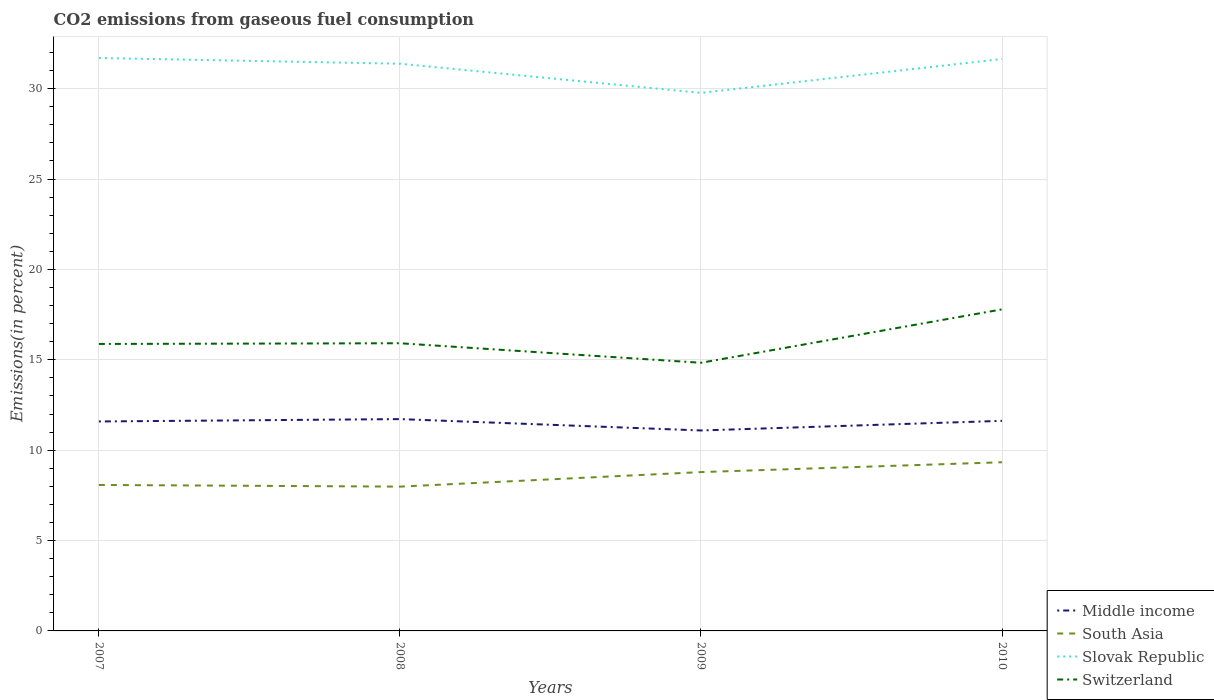How many different coloured lines are there?
Your answer should be compact. 4. Does the line corresponding to Slovak Republic intersect with the line corresponding to Middle income?
Your response must be concise. No. Is the number of lines equal to the number of legend labels?
Your answer should be compact. Yes. Across all years, what is the maximum total CO2 emitted in Middle income?
Ensure brevity in your answer.  11.09. What is the total total CO2 emitted in Switzerland in the graph?
Ensure brevity in your answer.  -1.87. What is the difference between the highest and the second highest total CO2 emitted in Slovak Republic?
Offer a terse response. 1.93. What is the difference between the highest and the lowest total CO2 emitted in Middle income?
Ensure brevity in your answer.  3. Is the total CO2 emitted in South Asia strictly greater than the total CO2 emitted in Switzerland over the years?
Your response must be concise. Yes. How many years are there in the graph?
Provide a short and direct response. 4. What is the difference between two consecutive major ticks on the Y-axis?
Provide a short and direct response. 5. Are the values on the major ticks of Y-axis written in scientific E-notation?
Ensure brevity in your answer.  No. Does the graph contain any zero values?
Your answer should be very brief. No. Where does the legend appear in the graph?
Provide a short and direct response. Bottom right. How are the legend labels stacked?
Your response must be concise. Vertical. What is the title of the graph?
Offer a very short reply. CO2 emissions from gaseous fuel consumption. Does "Uganda" appear as one of the legend labels in the graph?
Your answer should be compact. No. What is the label or title of the X-axis?
Your answer should be compact. Years. What is the label or title of the Y-axis?
Offer a terse response. Emissions(in percent). What is the Emissions(in percent) of Middle income in 2007?
Offer a very short reply. 11.59. What is the Emissions(in percent) in South Asia in 2007?
Make the answer very short. 8.08. What is the Emissions(in percent) in Slovak Republic in 2007?
Make the answer very short. 31.69. What is the Emissions(in percent) of Switzerland in 2007?
Ensure brevity in your answer.  15.88. What is the Emissions(in percent) in Middle income in 2008?
Your answer should be compact. 11.72. What is the Emissions(in percent) in South Asia in 2008?
Provide a succinct answer. 7.98. What is the Emissions(in percent) of Slovak Republic in 2008?
Your response must be concise. 31.38. What is the Emissions(in percent) in Switzerland in 2008?
Provide a succinct answer. 15.91. What is the Emissions(in percent) in Middle income in 2009?
Offer a terse response. 11.09. What is the Emissions(in percent) in South Asia in 2009?
Keep it short and to the point. 8.79. What is the Emissions(in percent) of Slovak Republic in 2009?
Ensure brevity in your answer.  29.77. What is the Emissions(in percent) in Switzerland in 2009?
Your answer should be compact. 14.83. What is the Emissions(in percent) of Middle income in 2010?
Make the answer very short. 11.62. What is the Emissions(in percent) in South Asia in 2010?
Offer a terse response. 9.33. What is the Emissions(in percent) in Slovak Republic in 2010?
Offer a very short reply. 31.64. What is the Emissions(in percent) in Switzerland in 2010?
Make the answer very short. 17.79. Across all years, what is the maximum Emissions(in percent) of Middle income?
Your answer should be compact. 11.72. Across all years, what is the maximum Emissions(in percent) in South Asia?
Give a very brief answer. 9.33. Across all years, what is the maximum Emissions(in percent) of Slovak Republic?
Offer a very short reply. 31.69. Across all years, what is the maximum Emissions(in percent) of Switzerland?
Your answer should be compact. 17.79. Across all years, what is the minimum Emissions(in percent) of Middle income?
Make the answer very short. 11.09. Across all years, what is the minimum Emissions(in percent) of South Asia?
Make the answer very short. 7.98. Across all years, what is the minimum Emissions(in percent) in Slovak Republic?
Keep it short and to the point. 29.77. Across all years, what is the minimum Emissions(in percent) in Switzerland?
Keep it short and to the point. 14.83. What is the total Emissions(in percent) of Middle income in the graph?
Your answer should be compact. 46.02. What is the total Emissions(in percent) of South Asia in the graph?
Offer a very short reply. 34.18. What is the total Emissions(in percent) of Slovak Republic in the graph?
Your response must be concise. 124.48. What is the total Emissions(in percent) of Switzerland in the graph?
Provide a short and direct response. 64.41. What is the difference between the Emissions(in percent) of Middle income in 2007 and that in 2008?
Provide a short and direct response. -0.13. What is the difference between the Emissions(in percent) of South Asia in 2007 and that in 2008?
Your answer should be compact. 0.09. What is the difference between the Emissions(in percent) of Slovak Republic in 2007 and that in 2008?
Offer a terse response. 0.32. What is the difference between the Emissions(in percent) of Switzerland in 2007 and that in 2008?
Ensure brevity in your answer.  -0.04. What is the difference between the Emissions(in percent) in Middle income in 2007 and that in 2009?
Provide a short and direct response. 0.5. What is the difference between the Emissions(in percent) of South Asia in 2007 and that in 2009?
Give a very brief answer. -0.71. What is the difference between the Emissions(in percent) in Slovak Republic in 2007 and that in 2009?
Provide a short and direct response. 1.93. What is the difference between the Emissions(in percent) in Switzerland in 2007 and that in 2009?
Make the answer very short. 1.04. What is the difference between the Emissions(in percent) of Middle income in 2007 and that in 2010?
Provide a succinct answer. -0.03. What is the difference between the Emissions(in percent) in South Asia in 2007 and that in 2010?
Provide a short and direct response. -1.26. What is the difference between the Emissions(in percent) in Slovak Republic in 2007 and that in 2010?
Give a very brief answer. 0.05. What is the difference between the Emissions(in percent) in Switzerland in 2007 and that in 2010?
Your answer should be very brief. -1.91. What is the difference between the Emissions(in percent) of Middle income in 2008 and that in 2009?
Give a very brief answer. 0.63. What is the difference between the Emissions(in percent) of South Asia in 2008 and that in 2009?
Provide a succinct answer. -0.8. What is the difference between the Emissions(in percent) of Slovak Republic in 2008 and that in 2009?
Keep it short and to the point. 1.61. What is the difference between the Emissions(in percent) of Switzerland in 2008 and that in 2009?
Your answer should be compact. 1.08. What is the difference between the Emissions(in percent) of Middle income in 2008 and that in 2010?
Your answer should be very brief. 0.1. What is the difference between the Emissions(in percent) in South Asia in 2008 and that in 2010?
Provide a short and direct response. -1.35. What is the difference between the Emissions(in percent) of Slovak Republic in 2008 and that in 2010?
Provide a succinct answer. -0.26. What is the difference between the Emissions(in percent) of Switzerland in 2008 and that in 2010?
Provide a short and direct response. -1.87. What is the difference between the Emissions(in percent) of Middle income in 2009 and that in 2010?
Offer a terse response. -0.53. What is the difference between the Emissions(in percent) in South Asia in 2009 and that in 2010?
Offer a terse response. -0.54. What is the difference between the Emissions(in percent) of Slovak Republic in 2009 and that in 2010?
Keep it short and to the point. -1.87. What is the difference between the Emissions(in percent) of Switzerland in 2009 and that in 2010?
Ensure brevity in your answer.  -2.95. What is the difference between the Emissions(in percent) in Middle income in 2007 and the Emissions(in percent) in South Asia in 2008?
Offer a very short reply. 3.6. What is the difference between the Emissions(in percent) of Middle income in 2007 and the Emissions(in percent) of Slovak Republic in 2008?
Keep it short and to the point. -19.79. What is the difference between the Emissions(in percent) in Middle income in 2007 and the Emissions(in percent) in Switzerland in 2008?
Your answer should be very brief. -4.33. What is the difference between the Emissions(in percent) in South Asia in 2007 and the Emissions(in percent) in Slovak Republic in 2008?
Your answer should be compact. -23.3. What is the difference between the Emissions(in percent) of South Asia in 2007 and the Emissions(in percent) of Switzerland in 2008?
Provide a succinct answer. -7.84. What is the difference between the Emissions(in percent) of Slovak Republic in 2007 and the Emissions(in percent) of Switzerland in 2008?
Provide a succinct answer. 15.78. What is the difference between the Emissions(in percent) in Middle income in 2007 and the Emissions(in percent) in South Asia in 2009?
Make the answer very short. 2.8. What is the difference between the Emissions(in percent) in Middle income in 2007 and the Emissions(in percent) in Slovak Republic in 2009?
Your answer should be very brief. -18.18. What is the difference between the Emissions(in percent) in Middle income in 2007 and the Emissions(in percent) in Switzerland in 2009?
Offer a terse response. -3.25. What is the difference between the Emissions(in percent) in South Asia in 2007 and the Emissions(in percent) in Slovak Republic in 2009?
Provide a succinct answer. -21.69. What is the difference between the Emissions(in percent) in South Asia in 2007 and the Emissions(in percent) in Switzerland in 2009?
Your response must be concise. -6.76. What is the difference between the Emissions(in percent) of Slovak Republic in 2007 and the Emissions(in percent) of Switzerland in 2009?
Ensure brevity in your answer.  16.86. What is the difference between the Emissions(in percent) in Middle income in 2007 and the Emissions(in percent) in South Asia in 2010?
Ensure brevity in your answer.  2.26. What is the difference between the Emissions(in percent) in Middle income in 2007 and the Emissions(in percent) in Slovak Republic in 2010?
Offer a terse response. -20.05. What is the difference between the Emissions(in percent) in Middle income in 2007 and the Emissions(in percent) in Switzerland in 2010?
Give a very brief answer. -6.2. What is the difference between the Emissions(in percent) in South Asia in 2007 and the Emissions(in percent) in Slovak Republic in 2010?
Offer a terse response. -23.56. What is the difference between the Emissions(in percent) of South Asia in 2007 and the Emissions(in percent) of Switzerland in 2010?
Provide a short and direct response. -9.71. What is the difference between the Emissions(in percent) in Slovak Republic in 2007 and the Emissions(in percent) in Switzerland in 2010?
Your answer should be compact. 13.91. What is the difference between the Emissions(in percent) in Middle income in 2008 and the Emissions(in percent) in South Asia in 2009?
Keep it short and to the point. 2.93. What is the difference between the Emissions(in percent) of Middle income in 2008 and the Emissions(in percent) of Slovak Republic in 2009?
Provide a short and direct response. -18.05. What is the difference between the Emissions(in percent) of Middle income in 2008 and the Emissions(in percent) of Switzerland in 2009?
Keep it short and to the point. -3.12. What is the difference between the Emissions(in percent) of South Asia in 2008 and the Emissions(in percent) of Slovak Republic in 2009?
Your answer should be very brief. -21.78. What is the difference between the Emissions(in percent) of South Asia in 2008 and the Emissions(in percent) of Switzerland in 2009?
Give a very brief answer. -6.85. What is the difference between the Emissions(in percent) in Slovak Republic in 2008 and the Emissions(in percent) in Switzerland in 2009?
Offer a very short reply. 16.54. What is the difference between the Emissions(in percent) of Middle income in 2008 and the Emissions(in percent) of South Asia in 2010?
Your answer should be very brief. 2.39. What is the difference between the Emissions(in percent) of Middle income in 2008 and the Emissions(in percent) of Slovak Republic in 2010?
Keep it short and to the point. -19.92. What is the difference between the Emissions(in percent) of Middle income in 2008 and the Emissions(in percent) of Switzerland in 2010?
Give a very brief answer. -6.07. What is the difference between the Emissions(in percent) of South Asia in 2008 and the Emissions(in percent) of Slovak Republic in 2010?
Offer a very short reply. -23.66. What is the difference between the Emissions(in percent) of South Asia in 2008 and the Emissions(in percent) of Switzerland in 2010?
Your answer should be very brief. -9.81. What is the difference between the Emissions(in percent) in Slovak Republic in 2008 and the Emissions(in percent) in Switzerland in 2010?
Provide a short and direct response. 13.59. What is the difference between the Emissions(in percent) in Middle income in 2009 and the Emissions(in percent) in South Asia in 2010?
Provide a short and direct response. 1.76. What is the difference between the Emissions(in percent) of Middle income in 2009 and the Emissions(in percent) of Slovak Republic in 2010?
Keep it short and to the point. -20.55. What is the difference between the Emissions(in percent) of Middle income in 2009 and the Emissions(in percent) of Switzerland in 2010?
Provide a short and direct response. -6.7. What is the difference between the Emissions(in percent) of South Asia in 2009 and the Emissions(in percent) of Slovak Republic in 2010?
Provide a short and direct response. -22.85. What is the difference between the Emissions(in percent) of South Asia in 2009 and the Emissions(in percent) of Switzerland in 2010?
Your answer should be compact. -9. What is the difference between the Emissions(in percent) of Slovak Republic in 2009 and the Emissions(in percent) of Switzerland in 2010?
Give a very brief answer. 11.98. What is the average Emissions(in percent) of Middle income per year?
Keep it short and to the point. 11.5. What is the average Emissions(in percent) in South Asia per year?
Your response must be concise. 8.54. What is the average Emissions(in percent) of Slovak Republic per year?
Offer a terse response. 31.12. What is the average Emissions(in percent) of Switzerland per year?
Ensure brevity in your answer.  16.1. In the year 2007, what is the difference between the Emissions(in percent) of Middle income and Emissions(in percent) of South Asia?
Ensure brevity in your answer.  3.51. In the year 2007, what is the difference between the Emissions(in percent) of Middle income and Emissions(in percent) of Slovak Republic?
Make the answer very short. -20.11. In the year 2007, what is the difference between the Emissions(in percent) in Middle income and Emissions(in percent) in Switzerland?
Keep it short and to the point. -4.29. In the year 2007, what is the difference between the Emissions(in percent) of South Asia and Emissions(in percent) of Slovak Republic?
Provide a succinct answer. -23.62. In the year 2007, what is the difference between the Emissions(in percent) of South Asia and Emissions(in percent) of Switzerland?
Your answer should be very brief. -7.8. In the year 2007, what is the difference between the Emissions(in percent) of Slovak Republic and Emissions(in percent) of Switzerland?
Provide a succinct answer. 15.82. In the year 2008, what is the difference between the Emissions(in percent) of Middle income and Emissions(in percent) of South Asia?
Keep it short and to the point. 3.74. In the year 2008, what is the difference between the Emissions(in percent) in Middle income and Emissions(in percent) in Slovak Republic?
Your response must be concise. -19.66. In the year 2008, what is the difference between the Emissions(in percent) in Middle income and Emissions(in percent) in Switzerland?
Your answer should be very brief. -4.2. In the year 2008, what is the difference between the Emissions(in percent) in South Asia and Emissions(in percent) in Slovak Republic?
Offer a terse response. -23.4. In the year 2008, what is the difference between the Emissions(in percent) of South Asia and Emissions(in percent) of Switzerland?
Your answer should be very brief. -7.93. In the year 2008, what is the difference between the Emissions(in percent) of Slovak Republic and Emissions(in percent) of Switzerland?
Your response must be concise. 15.46. In the year 2009, what is the difference between the Emissions(in percent) of Middle income and Emissions(in percent) of South Asia?
Make the answer very short. 2.3. In the year 2009, what is the difference between the Emissions(in percent) of Middle income and Emissions(in percent) of Slovak Republic?
Keep it short and to the point. -18.68. In the year 2009, what is the difference between the Emissions(in percent) of Middle income and Emissions(in percent) of Switzerland?
Ensure brevity in your answer.  -3.74. In the year 2009, what is the difference between the Emissions(in percent) in South Asia and Emissions(in percent) in Slovak Republic?
Offer a terse response. -20.98. In the year 2009, what is the difference between the Emissions(in percent) in South Asia and Emissions(in percent) in Switzerland?
Your answer should be compact. -6.05. In the year 2009, what is the difference between the Emissions(in percent) of Slovak Republic and Emissions(in percent) of Switzerland?
Offer a very short reply. 14.93. In the year 2010, what is the difference between the Emissions(in percent) of Middle income and Emissions(in percent) of South Asia?
Keep it short and to the point. 2.29. In the year 2010, what is the difference between the Emissions(in percent) of Middle income and Emissions(in percent) of Slovak Republic?
Give a very brief answer. -20.02. In the year 2010, what is the difference between the Emissions(in percent) in Middle income and Emissions(in percent) in Switzerland?
Make the answer very short. -6.17. In the year 2010, what is the difference between the Emissions(in percent) of South Asia and Emissions(in percent) of Slovak Republic?
Your answer should be compact. -22.31. In the year 2010, what is the difference between the Emissions(in percent) in South Asia and Emissions(in percent) in Switzerland?
Provide a short and direct response. -8.46. In the year 2010, what is the difference between the Emissions(in percent) in Slovak Republic and Emissions(in percent) in Switzerland?
Offer a terse response. 13.85. What is the ratio of the Emissions(in percent) in Middle income in 2007 to that in 2008?
Your response must be concise. 0.99. What is the ratio of the Emissions(in percent) of South Asia in 2007 to that in 2008?
Your answer should be compact. 1.01. What is the ratio of the Emissions(in percent) of Slovak Republic in 2007 to that in 2008?
Your answer should be compact. 1.01. What is the ratio of the Emissions(in percent) in Switzerland in 2007 to that in 2008?
Your answer should be very brief. 1. What is the ratio of the Emissions(in percent) in Middle income in 2007 to that in 2009?
Make the answer very short. 1.04. What is the ratio of the Emissions(in percent) in South Asia in 2007 to that in 2009?
Your response must be concise. 0.92. What is the ratio of the Emissions(in percent) in Slovak Republic in 2007 to that in 2009?
Give a very brief answer. 1.06. What is the ratio of the Emissions(in percent) in Switzerland in 2007 to that in 2009?
Keep it short and to the point. 1.07. What is the ratio of the Emissions(in percent) in South Asia in 2007 to that in 2010?
Provide a succinct answer. 0.87. What is the ratio of the Emissions(in percent) of Slovak Republic in 2007 to that in 2010?
Make the answer very short. 1. What is the ratio of the Emissions(in percent) of Switzerland in 2007 to that in 2010?
Ensure brevity in your answer.  0.89. What is the ratio of the Emissions(in percent) in Middle income in 2008 to that in 2009?
Make the answer very short. 1.06. What is the ratio of the Emissions(in percent) in South Asia in 2008 to that in 2009?
Offer a very short reply. 0.91. What is the ratio of the Emissions(in percent) of Slovak Republic in 2008 to that in 2009?
Offer a very short reply. 1.05. What is the ratio of the Emissions(in percent) of Switzerland in 2008 to that in 2009?
Your response must be concise. 1.07. What is the ratio of the Emissions(in percent) of Middle income in 2008 to that in 2010?
Ensure brevity in your answer.  1.01. What is the ratio of the Emissions(in percent) in South Asia in 2008 to that in 2010?
Offer a very short reply. 0.86. What is the ratio of the Emissions(in percent) of Switzerland in 2008 to that in 2010?
Give a very brief answer. 0.89. What is the ratio of the Emissions(in percent) in Middle income in 2009 to that in 2010?
Offer a very short reply. 0.95. What is the ratio of the Emissions(in percent) in South Asia in 2009 to that in 2010?
Your response must be concise. 0.94. What is the ratio of the Emissions(in percent) of Slovak Republic in 2009 to that in 2010?
Your response must be concise. 0.94. What is the ratio of the Emissions(in percent) of Switzerland in 2009 to that in 2010?
Offer a terse response. 0.83. What is the difference between the highest and the second highest Emissions(in percent) of Middle income?
Your response must be concise. 0.1. What is the difference between the highest and the second highest Emissions(in percent) in South Asia?
Your response must be concise. 0.54. What is the difference between the highest and the second highest Emissions(in percent) of Slovak Republic?
Give a very brief answer. 0.05. What is the difference between the highest and the second highest Emissions(in percent) of Switzerland?
Your answer should be very brief. 1.87. What is the difference between the highest and the lowest Emissions(in percent) of Middle income?
Give a very brief answer. 0.63. What is the difference between the highest and the lowest Emissions(in percent) in South Asia?
Give a very brief answer. 1.35. What is the difference between the highest and the lowest Emissions(in percent) in Slovak Republic?
Your answer should be compact. 1.93. What is the difference between the highest and the lowest Emissions(in percent) in Switzerland?
Provide a short and direct response. 2.95. 